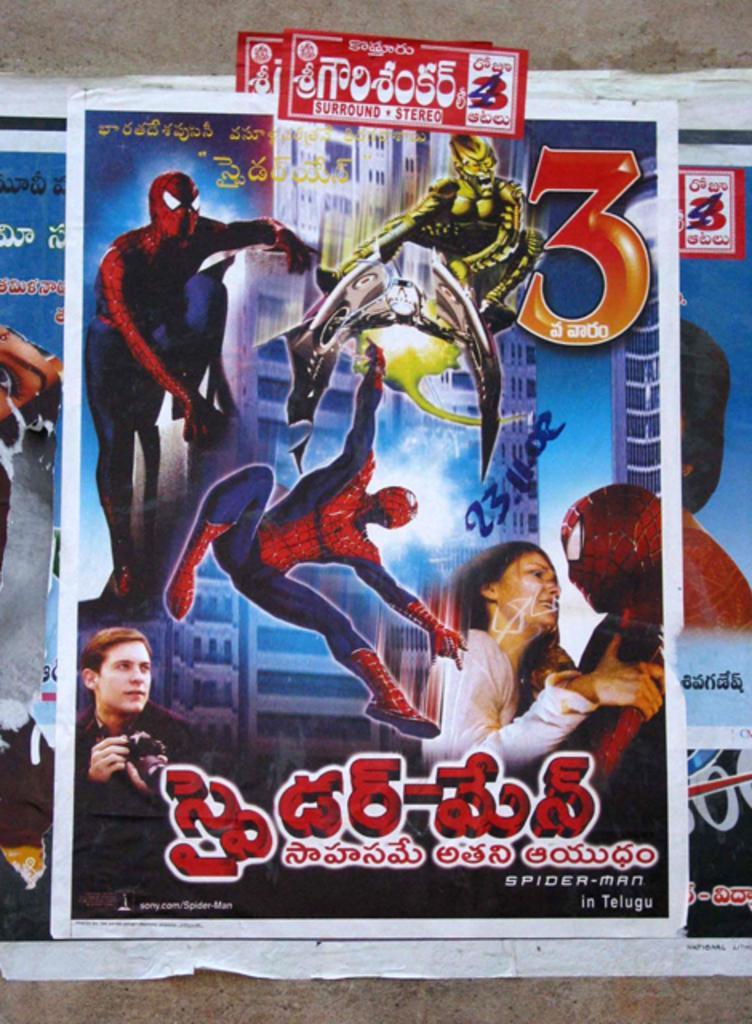Could you give a brief overview of what you see in this image? Here in this picture we can see posts of a spider man movie present on the wall. 